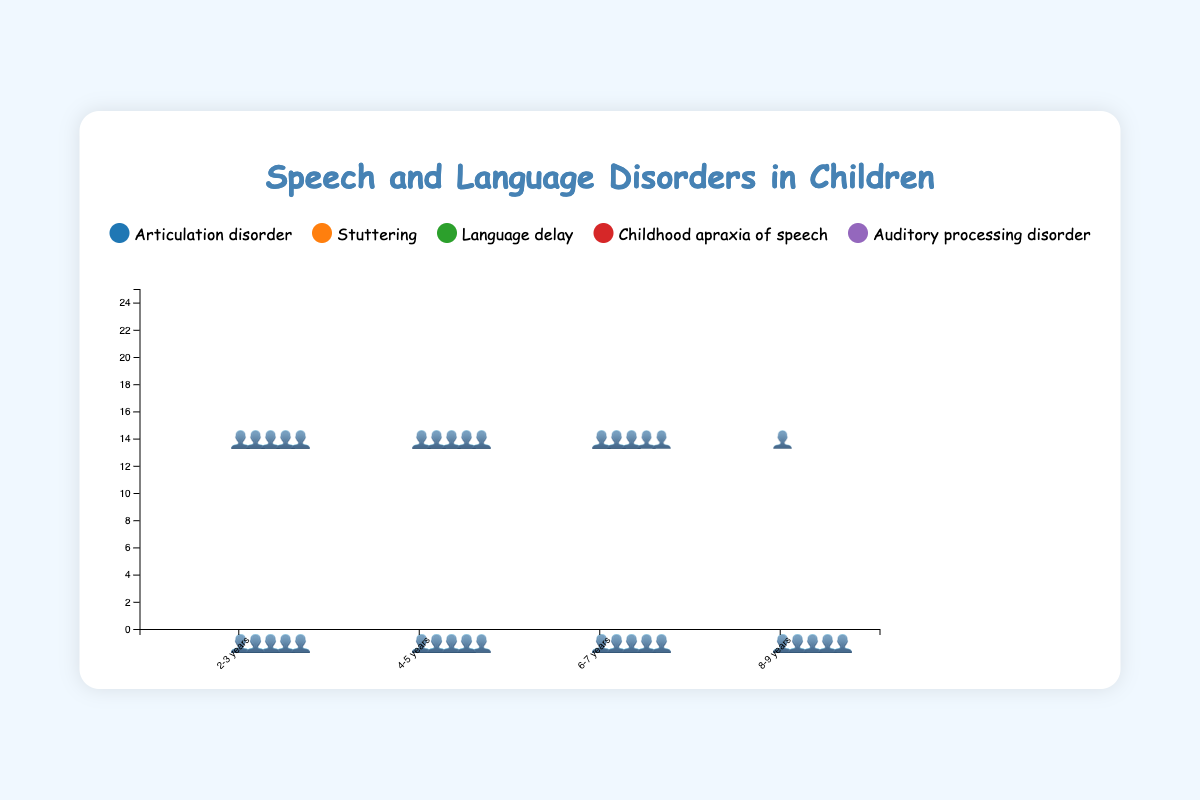What's the title of the figure? The title is usually located at the top of the figure. By checking there, you'll find the exact text used as the title.
Answer: Speech and Language Disorders in Children Which age group has the highest prevalence of language delay? By looking at the symbols (👤) for language delay across all age groups, you’ll notice that the 2-3 years group has the most symbols representing it.
Answer: 2-3 years What is the overall trend in prevalence for articulation disorder as children grow older? By observing the number of symbols representing articulation disorder across different age groups, you can see that the prevalence decreases as the age increases.
Answer: Decreasing How does the prevalence of auditory processing disorder change across age groups? By counting the symbols (👤) representing auditory processing disorder, you can see that it generally increases from 2-3 years to 8-9 years.
Answer: Increases Which disorder has the least prevalence in the 2-3 years age group? By comparing the number of symbols (👤) for each disorder within the 2-3 years age group, you can see that childhood apraxia of speech has the fewest symbols.
Answer: Childhood apraxia of speech How does stuttering prevalence compare between the age groups 4-5 years and 8-9 years? For stuttering, compare the number of symbols (👤) between the 4-5 years and 8-9 years age groups. The 4-5 years group has more symbols than the 8-9 years group.
Answer: 4-5 years is higher What is the difference in prevalence of language delay between the 2-3 years and the 6-7 years age group? By subtracting the number of symbols for language delay in the 6-7 years age group from the number in the 2-3 years age group (20 - 10), we get 10.
Answer: 10 Which speech and language disorder maintains a relatively stable prevalence across age groups? By examining the number of symbols (👤) for each disorder across all age groups, it's evident that childhood apraxia of speech remains relatively stable.
Answer: Childhood apraxia of speech What is the average prevalence of stuttering across all age groups? The prevalences of stuttering across the age groups are 5, 4, 3, and 2. Sum these up (5 + 4 + 3 + 2 = 14), then divide by the number of groups (14/4 = 3.5).
Answer: 3.5 